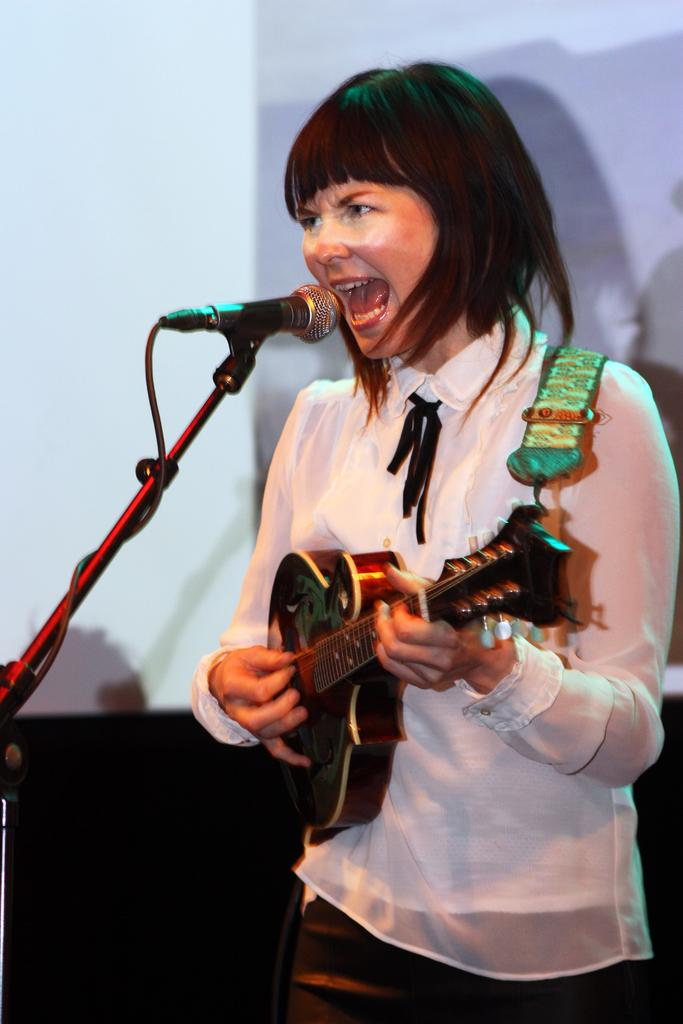Who is the main subject in the image? There is a woman in the image. What is the woman doing in the image? The woman is singing and playing a guitar. What object is present in the image that is commonly used for amplifying sound? There is a microphone in the image. Can you see any fruit being delivered by a parcel service in the image? There is no fruit or parcel service present in the image. Is the woman in the image giving a kiss to someone? There is no indication of a kiss or any other physical interaction in the image. 